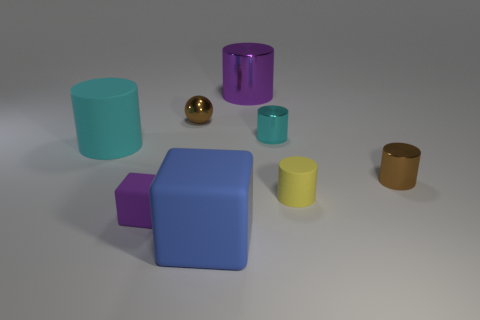Subtract all green cubes. How many cyan cylinders are left? 2 Subtract all large cylinders. How many cylinders are left? 3 Subtract all purple cylinders. How many cylinders are left? 4 Subtract 1 cylinders. How many cylinders are left? 4 Add 1 red metal cubes. How many objects exist? 9 Subtract all blue cylinders. Subtract all green spheres. How many cylinders are left? 5 Subtract 0 yellow spheres. How many objects are left? 8 Subtract all blocks. How many objects are left? 6 Subtract all tiny cylinders. Subtract all large purple objects. How many objects are left? 4 Add 8 small cyan cylinders. How many small cyan cylinders are left? 9 